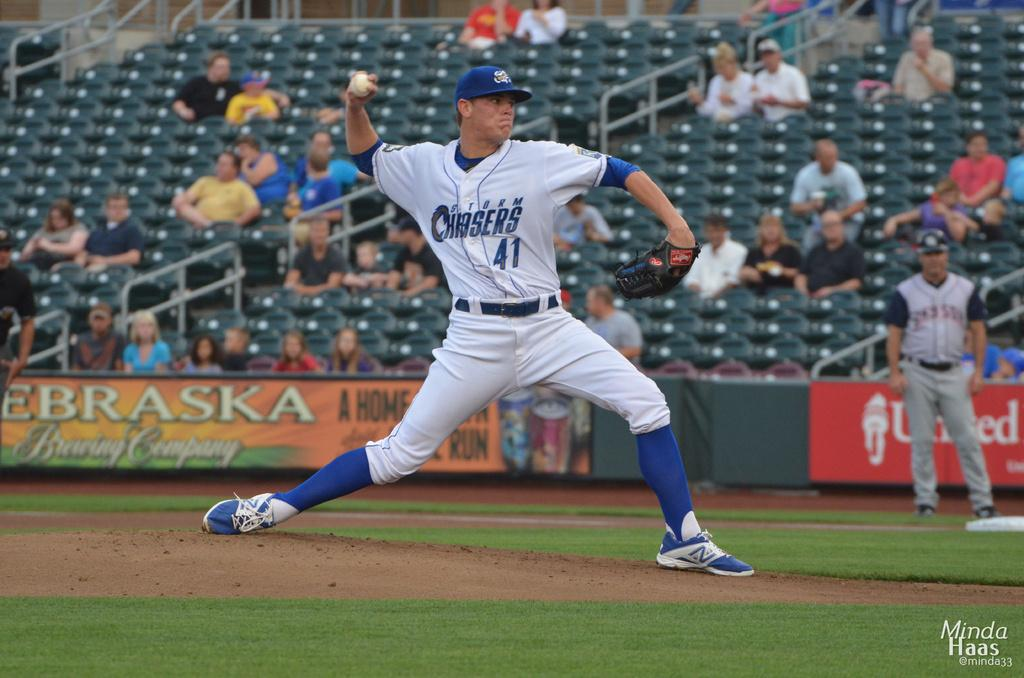Provide a one-sentence caption for the provided image. number 41 of the Storm Chasers is pitching the ball. 